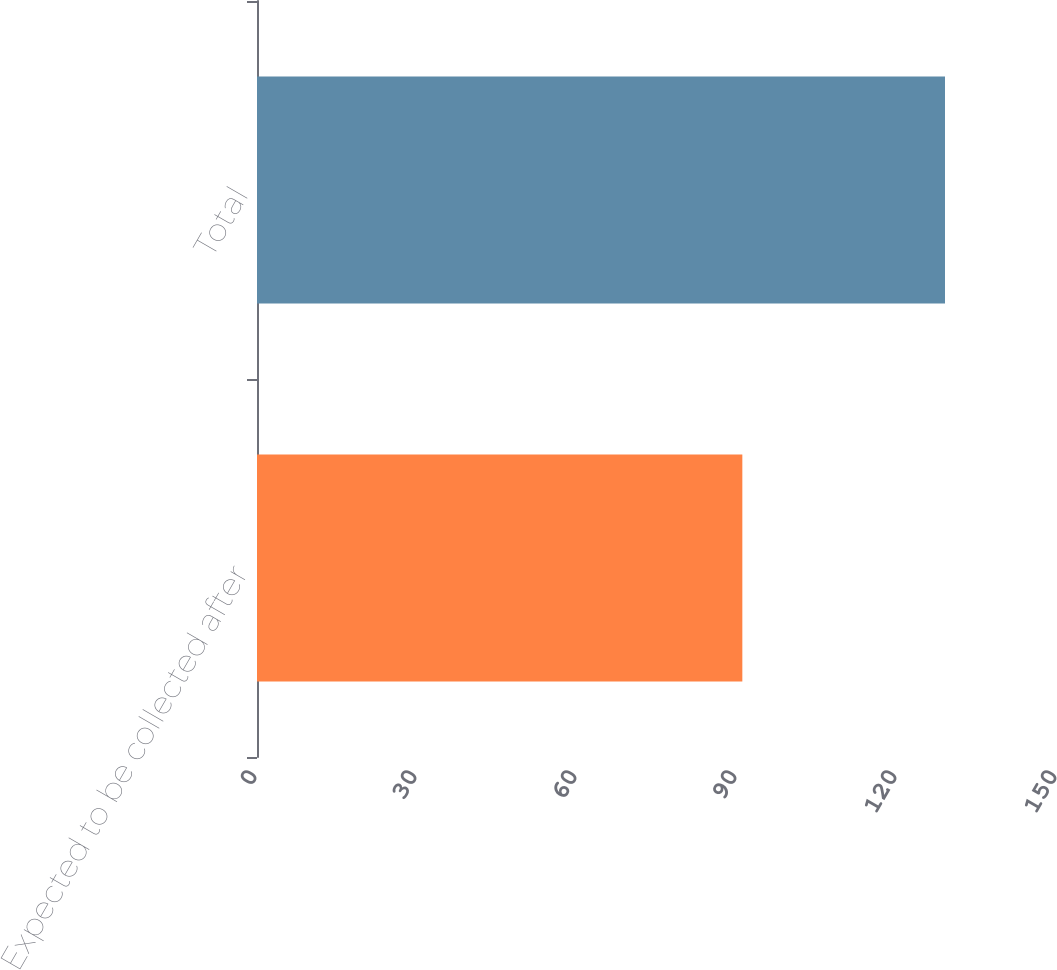Convert chart. <chart><loc_0><loc_0><loc_500><loc_500><bar_chart><fcel>Expected to be collected after<fcel>Total<nl><fcel>91<fcel>129<nl></chart> 